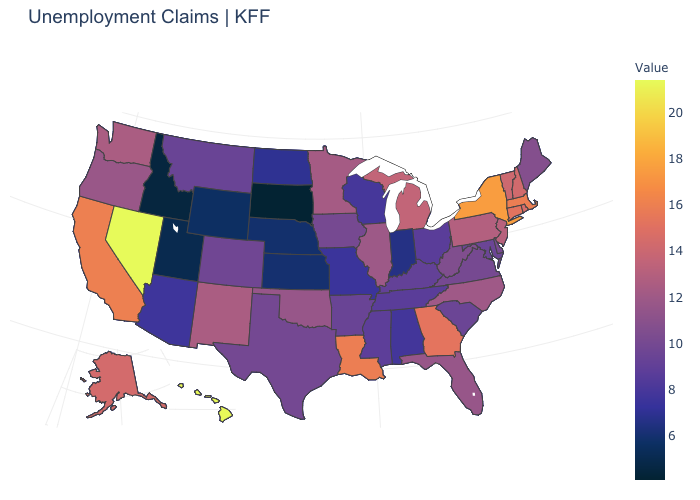Is the legend a continuous bar?
Concise answer only. Yes. Is the legend a continuous bar?
Concise answer only. Yes. Does Maine have the lowest value in the Northeast?
Write a very short answer. Yes. Is the legend a continuous bar?
Concise answer only. Yes. Is the legend a continuous bar?
Short answer required. Yes. Does the map have missing data?
Short answer required. No. Which states hav the highest value in the MidWest?
Give a very brief answer. Michigan. Does Washington have a lower value than Alaska?
Concise answer only. Yes. 